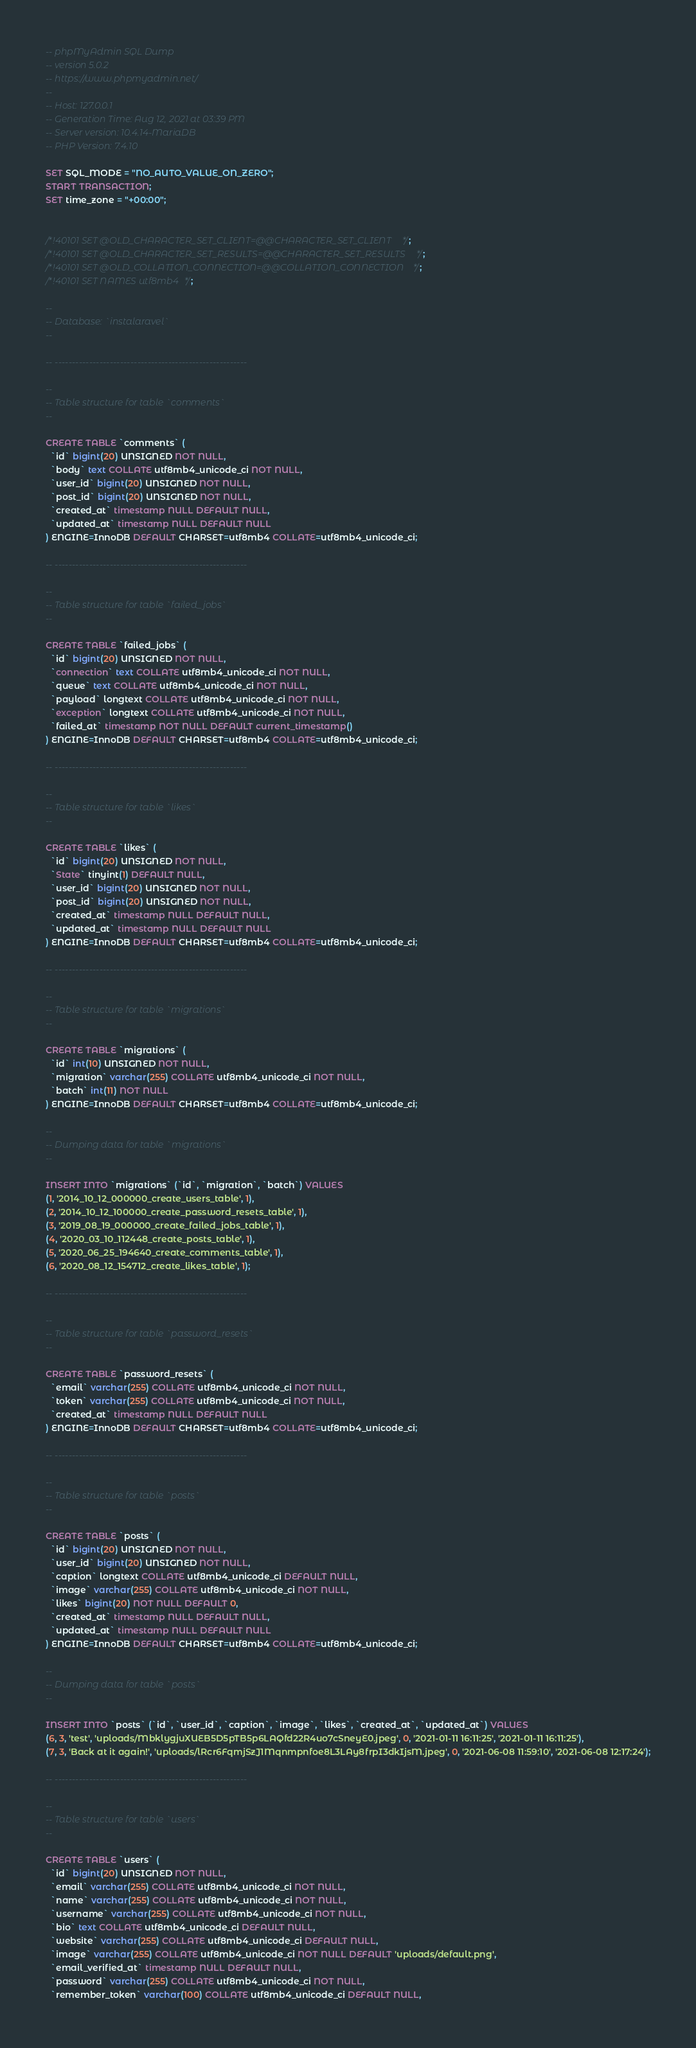Convert code to text. <code><loc_0><loc_0><loc_500><loc_500><_SQL_>-- phpMyAdmin SQL Dump
-- version 5.0.2
-- https://www.phpmyadmin.net/
--
-- Host: 127.0.0.1
-- Generation Time: Aug 12, 2021 at 03:39 PM
-- Server version: 10.4.14-MariaDB
-- PHP Version: 7.4.10

SET SQL_MODE = "NO_AUTO_VALUE_ON_ZERO";
START TRANSACTION;
SET time_zone = "+00:00";


/*!40101 SET @OLD_CHARACTER_SET_CLIENT=@@CHARACTER_SET_CLIENT */;
/*!40101 SET @OLD_CHARACTER_SET_RESULTS=@@CHARACTER_SET_RESULTS */;
/*!40101 SET @OLD_COLLATION_CONNECTION=@@COLLATION_CONNECTION */;
/*!40101 SET NAMES utf8mb4 */;

--
-- Database: `instalaravel`
--

-- --------------------------------------------------------

--
-- Table structure for table `comments`
--

CREATE TABLE `comments` (
  `id` bigint(20) UNSIGNED NOT NULL,
  `body` text COLLATE utf8mb4_unicode_ci NOT NULL,
  `user_id` bigint(20) UNSIGNED NOT NULL,
  `post_id` bigint(20) UNSIGNED NOT NULL,
  `created_at` timestamp NULL DEFAULT NULL,
  `updated_at` timestamp NULL DEFAULT NULL
) ENGINE=InnoDB DEFAULT CHARSET=utf8mb4 COLLATE=utf8mb4_unicode_ci;

-- --------------------------------------------------------

--
-- Table structure for table `failed_jobs`
--

CREATE TABLE `failed_jobs` (
  `id` bigint(20) UNSIGNED NOT NULL,
  `connection` text COLLATE utf8mb4_unicode_ci NOT NULL,
  `queue` text COLLATE utf8mb4_unicode_ci NOT NULL,
  `payload` longtext COLLATE utf8mb4_unicode_ci NOT NULL,
  `exception` longtext COLLATE utf8mb4_unicode_ci NOT NULL,
  `failed_at` timestamp NOT NULL DEFAULT current_timestamp()
) ENGINE=InnoDB DEFAULT CHARSET=utf8mb4 COLLATE=utf8mb4_unicode_ci;

-- --------------------------------------------------------

--
-- Table structure for table `likes`
--

CREATE TABLE `likes` (
  `id` bigint(20) UNSIGNED NOT NULL,
  `State` tinyint(1) DEFAULT NULL,
  `user_id` bigint(20) UNSIGNED NOT NULL,
  `post_id` bigint(20) UNSIGNED NOT NULL,
  `created_at` timestamp NULL DEFAULT NULL,
  `updated_at` timestamp NULL DEFAULT NULL
) ENGINE=InnoDB DEFAULT CHARSET=utf8mb4 COLLATE=utf8mb4_unicode_ci;

-- --------------------------------------------------------

--
-- Table structure for table `migrations`
--

CREATE TABLE `migrations` (
  `id` int(10) UNSIGNED NOT NULL,
  `migration` varchar(255) COLLATE utf8mb4_unicode_ci NOT NULL,
  `batch` int(11) NOT NULL
) ENGINE=InnoDB DEFAULT CHARSET=utf8mb4 COLLATE=utf8mb4_unicode_ci;

--
-- Dumping data for table `migrations`
--

INSERT INTO `migrations` (`id`, `migration`, `batch`) VALUES
(1, '2014_10_12_000000_create_users_table', 1),
(2, '2014_10_12_100000_create_password_resets_table', 1),
(3, '2019_08_19_000000_create_failed_jobs_table', 1),
(4, '2020_03_10_112448_create_posts_table', 1),
(5, '2020_06_25_194640_create_comments_table', 1),
(6, '2020_08_12_154712_create_likes_table', 1);

-- --------------------------------------------------------

--
-- Table structure for table `password_resets`
--

CREATE TABLE `password_resets` (
  `email` varchar(255) COLLATE utf8mb4_unicode_ci NOT NULL,
  `token` varchar(255) COLLATE utf8mb4_unicode_ci NOT NULL,
  `created_at` timestamp NULL DEFAULT NULL
) ENGINE=InnoDB DEFAULT CHARSET=utf8mb4 COLLATE=utf8mb4_unicode_ci;

-- --------------------------------------------------------

--
-- Table structure for table `posts`
--

CREATE TABLE `posts` (
  `id` bigint(20) UNSIGNED NOT NULL,
  `user_id` bigint(20) UNSIGNED NOT NULL,
  `caption` longtext COLLATE utf8mb4_unicode_ci DEFAULT NULL,
  `image` varchar(255) COLLATE utf8mb4_unicode_ci NOT NULL,
  `likes` bigint(20) NOT NULL DEFAULT 0,
  `created_at` timestamp NULL DEFAULT NULL,
  `updated_at` timestamp NULL DEFAULT NULL
) ENGINE=InnoDB DEFAULT CHARSET=utf8mb4 COLLATE=utf8mb4_unicode_ci;

--
-- Dumping data for table `posts`
--

INSERT INTO `posts` (`id`, `user_id`, `caption`, `image`, `likes`, `created_at`, `updated_at`) VALUES
(6, 3, 'test', 'uploads/MbklygjuXUEB5D5pTB5p6LAQfd22R4uo7cSneyE0.jpeg', 0, '2021-01-11 16:11:25', '2021-01-11 16:11:25'),
(7, 3, 'Back at it again!', 'uploads/lRcr6FqmjSzJ1Mqnmpnfoe8L3LAy8frpI3dkIjsM.jpeg', 0, '2021-06-08 11:59:10', '2021-06-08 12:17:24');

-- --------------------------------------------------------

--
-- Table structure for table `users`
--

CREATE TABLE `users` (
  `id` bigint(20) UNSIGNED NOT NULL,
  `email` varchar(255) COLLATE utf8mb4_unicode_ci NOT NULL,
  `name` varchar(255) COLLATE utf8mb4_unicode_ci NOT NULL,
  `username` varchar(255) COLLATE utf8mb4_unicode_ci NOT NULL,
  `bio` text COLLATE utf8mb4_unicode_ci DEFAULT NULL,
  `website` varchar(255) COLLATE utf8mb4_unicode_ci DEFAULT NULL,
  `image` varchar(255) COLLATE utf8mb4_unicode_ci NOT NULL DEFAULT 'uploads/default.png',
  `email_verified_at` timestamp NULL DEFAULT NULL,
  `password` varchar(255) COLLATE utf8mb4_unicode_ci NOT NULL,
  `remember_token` varchar(100) COLLATE utf8mb4_unicode_ci DEFAULT NULL,</code> 